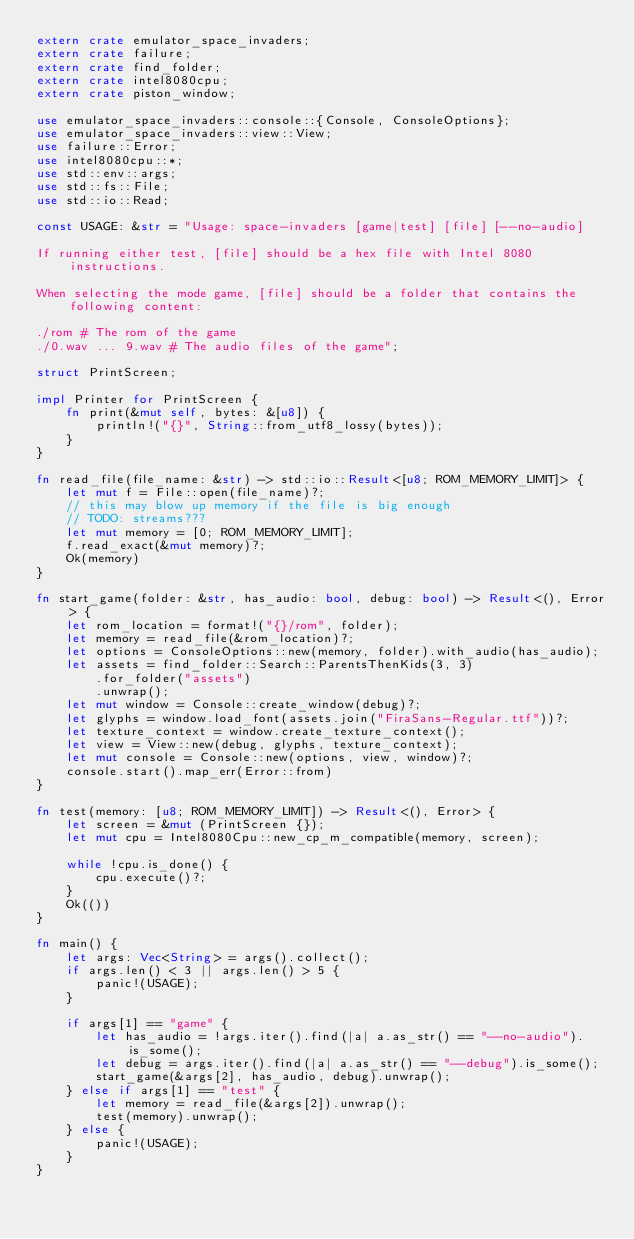Convert code to text. <code><loc_0><loc_0><loc_500><loc_500><_Rust_>extern crate emulator_space_invaders;
extern crate failure;
extern crate find_folder;
extern crate intel8080cpu;
extern crate piston_window;

use emulator_space_invaders::console::{Console, ConsoleOptions};
use emulator_space_invaders::view::View;
use failure::Error;
use intel8080cpu::*;
use std::env::args;
use std::fs::File;
use std::io::Read;

const USAGE: &str = "Usage: space-invaders [game|test] [file] [--no-audio]

If running either test, [file] should be a hex file with Intel 8080 instructions.

When selecting the mode game, [file] should be a folder that contains the following content:

./rom # The rom of the game
./0.wav ... 9.wav # The audio files of the game";

struct PrintScreen;

impl Printer for PrintScreen {
    fn print(&mut self, bytes: &[u8]) {
        println!("{}", String::from_utf8_lossy(bytes));
    }
}

fn read_file(file_name: &str) -> std::io::Result<[u8; ROM_MEMORY_LIMIT]> {
    let mut f = File::open(file_name)?;
    // this may blow up memory if the file is big enough
    // TODO: streams???
    let mut memory = [0; ROM_MEMORY_LIMIT];
    f.read_exact(&mut memory)?;
    Ok(memory)
}

fn start_game(folder: &str, has_audio: bool, debug: bool) -> Result<(), Error> {
    let rom_location = format!("{}/rom", folder);
    let memory = read_file(&rom_location)?;
    let options = ConsoleOptions::new(memory, folder).with_audio(has_audio);
    let assets = find_folder::Search::ParentsThenKids(3, 3)
        .for_folder("assets")
        .unwrap();
    let mut window = Console::create_window(debug)?;
    let glyphs = window.load_font(assets.join("FiraSans-Regular.ttf"))?;
    let texture_context = window.create_texture_context();
    let view = View::new(debug, glyphs, texture_context);
    let mut console = Console::new(options, view, window)?;
    console.start().map_err(Error::from)
}

fn test(memory: [u8; ROM_MEMORY_LIMIT]) -> Result<(), Error> {
    let screen = &mut (PrintScreen {});
    let mut cpu = Intel8080Cpu::new_cp_m_compatible(memory, screen);

    while !cpu.is_done() {
        cpu.execute()?;
    }
    Ok(())
}

fn main() {
    let args: Vec<String> = args().collect();
    if args.len() < 3 || args.len() > 5 {
        panic!(USAGE);
    }

    if args[1] == "game" {
        let has_audio = !args.iter().find(|a| a.as_str() == "--no-audio").is_some();
        let debug = args.iter().find(|a| a.as_str() == "--debug").is_some();
        start_game(&args[2], has_audio, debug).unwrap();
    } else if args[1] == "test" {
        let memory = read_file(&args[2]).unwrap();
        test(memory).unwrap();
    } else {
        panic!(USAGE);
    }
}
</code> 